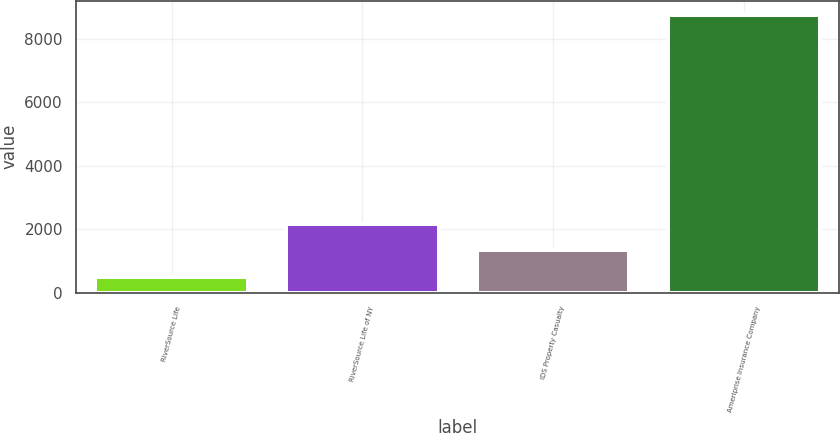Convert chart. <chart><loc_0><loc_0><loc_500><loc_500><bar_chart><fcel>RiverSource Life<fcel>RiverSource Life of NY<fcel>IDS Property Casualty<fcel>Ameriprise Insurance Company<nl><fcel>504<fcel>2155.4<fcel>1329.7<fcel>8761<nl></chart> 